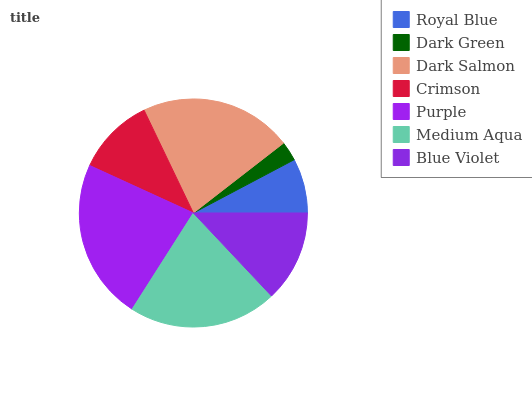Is Dark Green the minimum?
Answer yes or no. Yes. Is Purple the maximum?
Answer yes or no. Yes. Is Dark Salmon the minimum?
Answer yes or no. No. Is Dark Salmon the maximum?
Answer yes or no. No. Is Dark Salmon greater than Dark Green?
Answer yes or no. Yes. Is Dark Green less than Dark Salmon?
Answer yes or no. Yes. Is Dark Green greater than Dark Salmon?
Answer yes or no. No. Is Dark Salmon less than Dark Green?
Answer yes or no. No. Is Blue Violet the high median?
Answer yes or no. Yes. Is Blue Violet the low median?
Answer yes or no. Yes. Is Dark Salmon the high median?
Answer yes or no. No. Is Dark Green the low median?
Answer yes or no. No. 